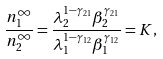<formula> <loc_0><loc_0><loc_500><loc_500>\frac { n _ { 1 } ^ { \infty } } { n _ { 2 } ^ { \infty } } = \frac { \lambda _ { 2 } ^ { 1 - \gamma _ { 2 1 } } \beta _ { 2 } ^ { \gamma _ { 2 1 } } } { \lambda _ { 1 } ^ { 1 - \gamma _ { 1 2 } } \beta _ { 1 } ^ { \gamma _ { 1 2 } } } = K ,</formula> 